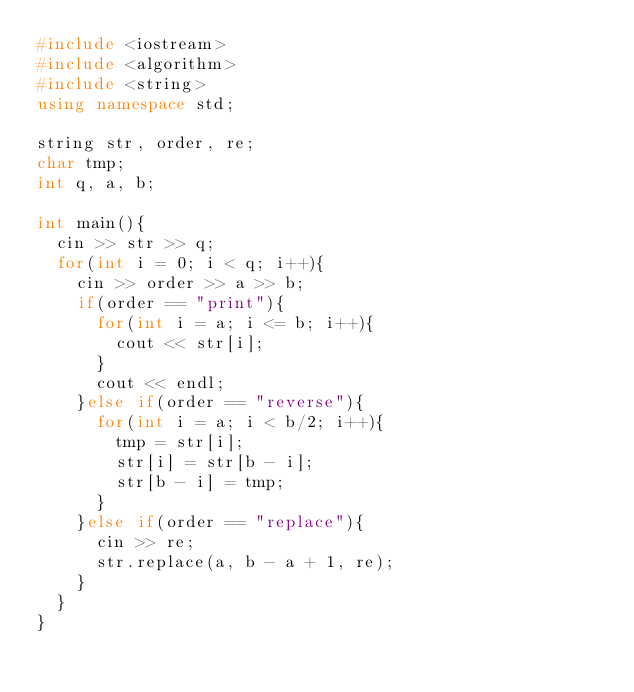<code> <loc_0><loc_0><loc_500><loc_500><_C++_>#include <iostream>
#include <algorithm>
#include <string>
using namespace std;

string str, order, re;
char tmp;
int q, a, b;

int main(){
  cin >> str >> q;
  for(int i = 0; i < q; i++){
    cin >> order >> a >> b;
    if(order == "print"){
      for(int i = a; i <= b; i++){
        cout << str[i];
      }
      cout << endl;
    }else if(order == "reverse"){
      for(int i = a; i < b/2; i++){
        tmp = str[i];
        str[i] = str[b - i];
        str[b - i] = tmp;
      }
    }else if(order == "replace"){
      cin >> re;
      str.replace(a, b - a + 1, re);
    }
  }
}</code> 